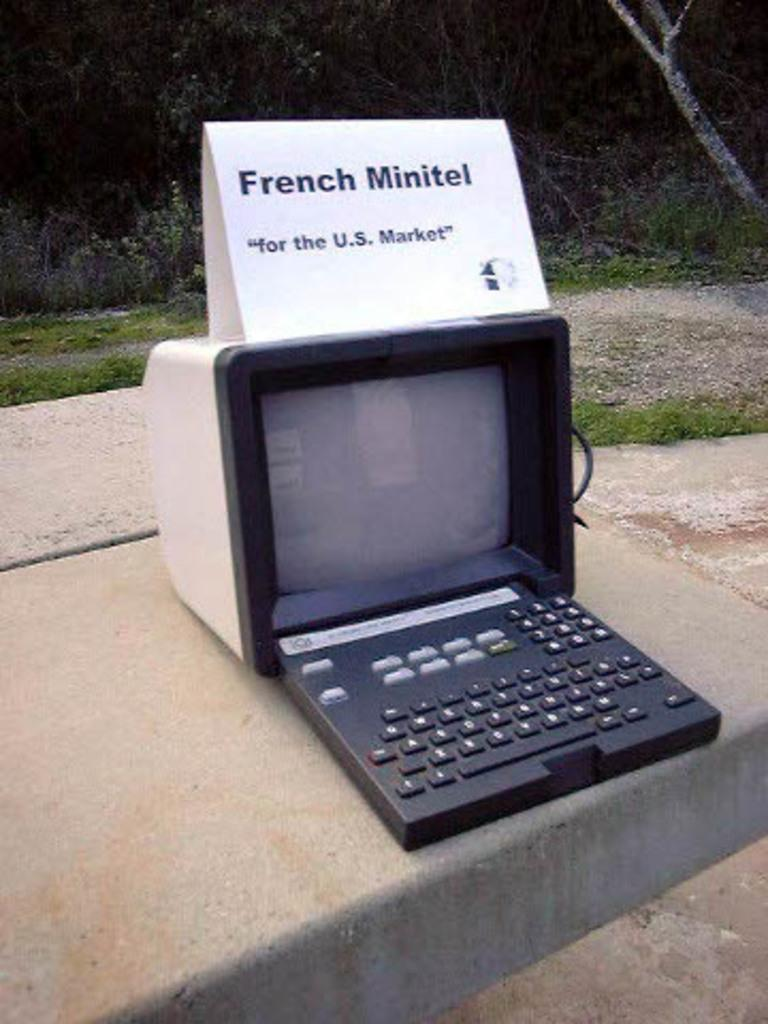<image>
Provide a brief description of the given image. A vintage computer with a French Minitel sign over it. 